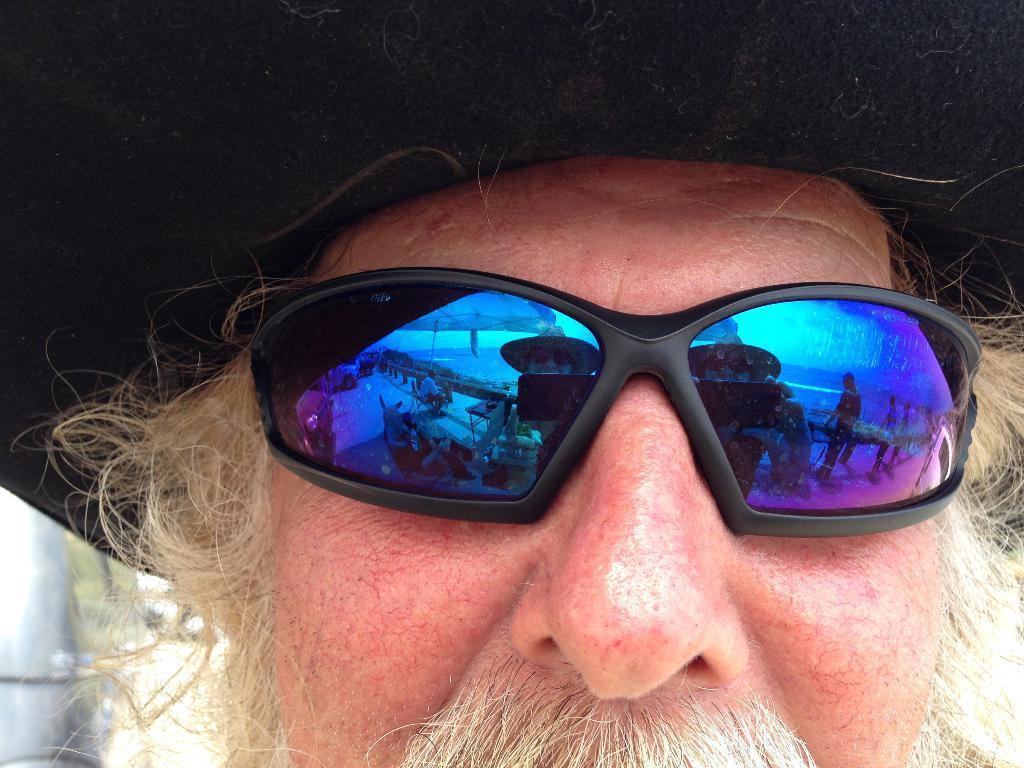Who is present in the image? There is a man in the image. What is the man wearing on his head? The man is wearing a hat. What type of eyewear is the man wearing? The man is wearing glasses. What type of paste is the man using to fly the kite in the image? There is no kite present in the image, and therefore no paste is being used. 